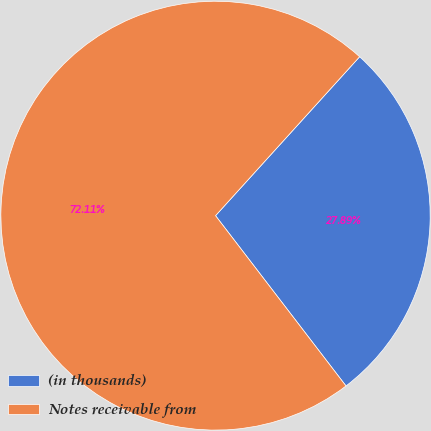Convert chart to OTSL. <chart><loc_0><loc_0><loc_500><loc_500><pie_chart><fcel>(in thousands)<fcel>Notes receivable from<nl><fcel>27.89%<fcel>72.11%<nl></chart> 